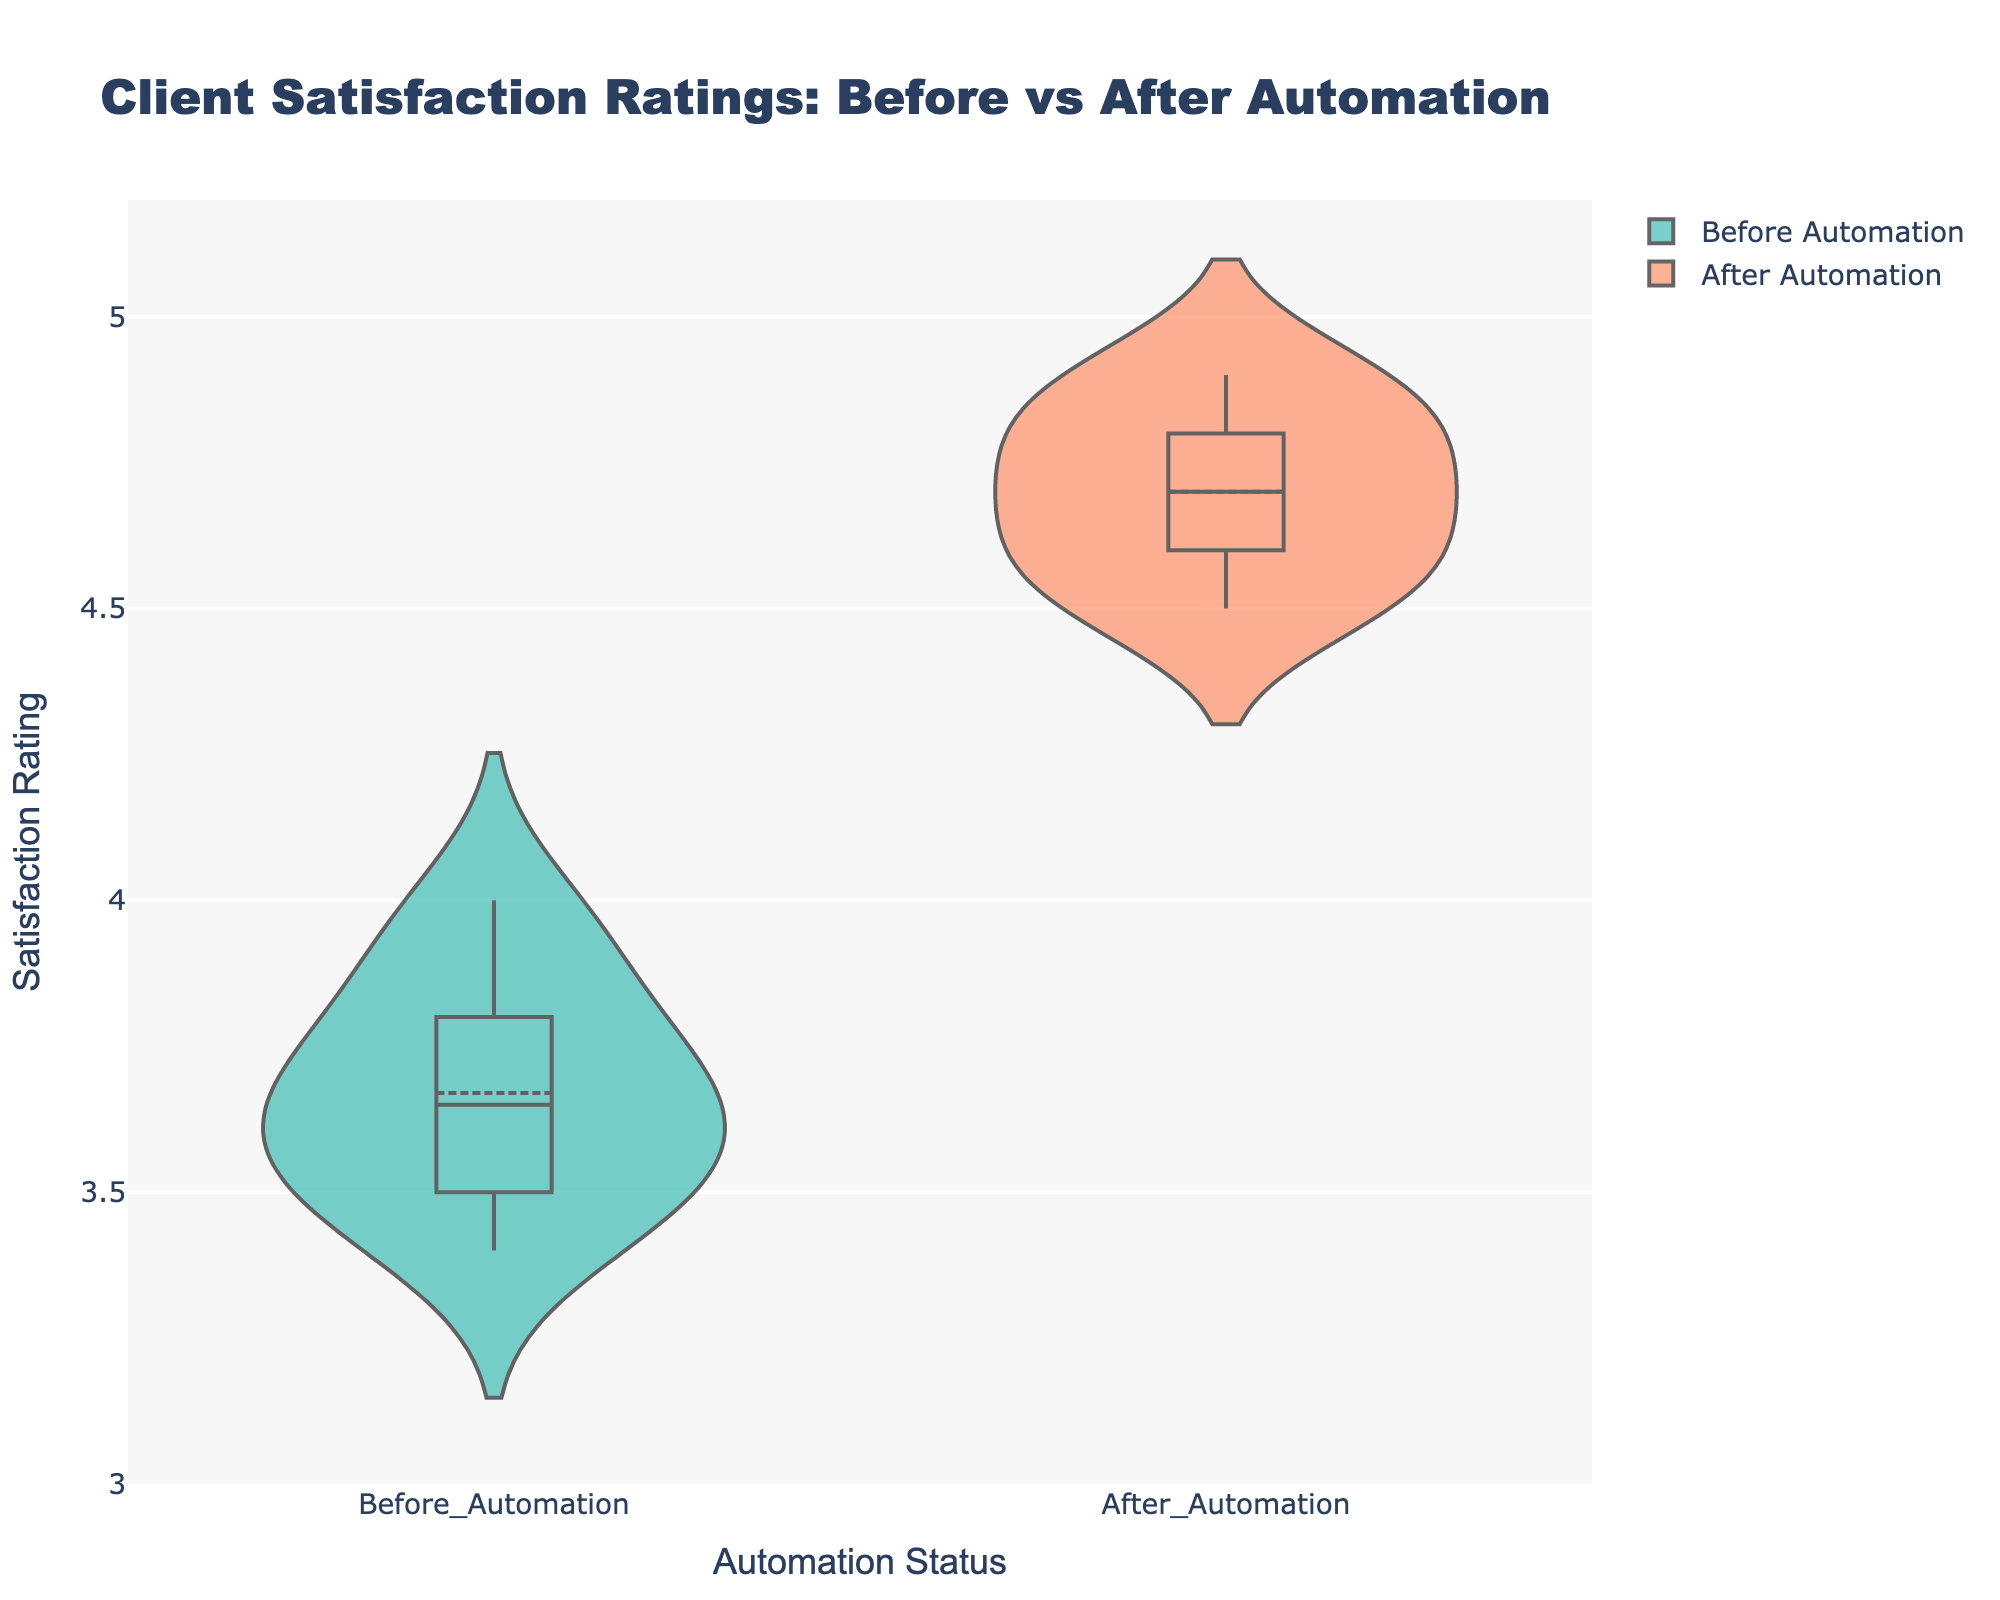What is the title of the figure? The title of the figure is located at the top and reads "Client Satisfaction Ratings: Before vs After Automation".
Answer: Client Satisfaction Ratings: Before vs After Automation What is the range of the y-axis? The y-axis range is clearly shown on the left side of the plot, and it ranges from 3 to 5.2.
Answer: 3 to 5.2 Which color represents the 'Before Automation' data? The 'Before Automation' data is represented by the light seagreen color as indicated by the color legend in the figure.
Answer: Light seagreen How many client satisfaction ratings are sampled for ‘Before Automation’? By counting the number of points or considering the data provided, there are 10 client satisfaction ratings for 'Before Automation'.
Answer: 10 What is the visible meanline of 'After Automation'? The meanline is visibly marked and located around the position of the average rating for 'After Automation', which is approximately 4.7.
Answer: Around 4.7 What is the median satisfaction rating for 'Before Automation'? The median line in the box plot for 'Before Automation' is drawn inside the violin plot. The median sits close to the middle point, around 3.7.
Answer: Around 3.7 Which period shows a higher median satisfaction rating? By comparing the median lines in each section, 'After Automation' shows a higher median satisfaction rating, around 4.7, compared to 'Before Automation' which is around 3.7.
Answer: After Automation What is the difference in the mean satisfaction ratings between 'Before Automation' and 'After Automation'? The mean of 'Before Automation' is approximately 3.67, and the mean of 'After Automation' is approximately 4.7. The difference is 4.7 - 3.67 = 1.03.
Answer: 1.03 Which data set has a wider spread of satisfaction ratings? By examining the width of the violin plots, 'Before Automation' shows a wider spread of ratings compared to 'After Automation' which is more concentrated.
Answer: Before Automation How does the distribution of satisfaction ratings change after automation integration? The 'After Automation' violin is narrower and more centered around higher values compared to 'Before Automation', indicating increased satisfaction with less variability.
Answer: Increased satisfaction with less variability 